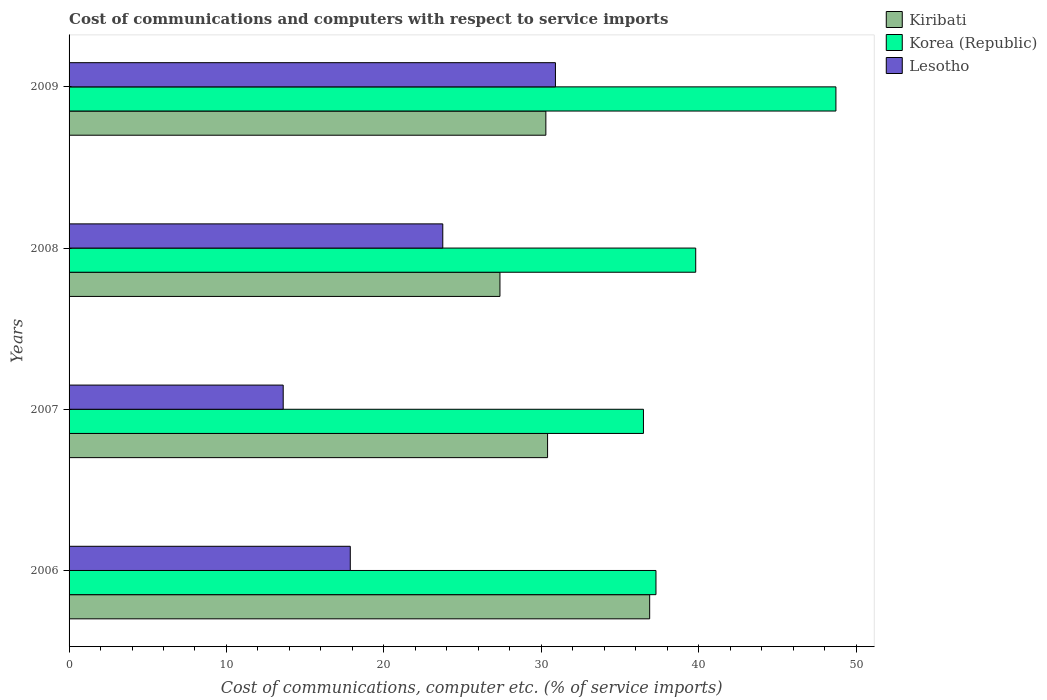Are the number of bars per tick equal to the number of legend labels?
Your answer should be very brief. Yes. Are the number of bars on each tick of the Y-axis equal?
Your answer should be compact. Yes. How many bars are there on the 3rd tick from the bottom?
Your answer should be compact. 3. In how many cases, is the number of bars for a given year not equal to the number of legend labels?
Your answer should be very brief. 0. What is the cost of communications and computers in Korea (Republic) in 2009?
Make the answer very short. 48.72. Across all years, what is the maximum cost of communications and computers in Lesotho?
Give a very brief answer. 30.9. Across all years, what is the minimum cost of communications and computers in Kiribati?
Your answer should be very brief. 27.38. What is the total cost of communications and computers in Kiribati in the graph?
Your answer should be compact. 124.96. What is the difference between the cost of communications and computers in Lesotho in 2006 and that in 2007?
Offer a very short reply. 4.26. What is the difference between the cost of communications and computers in Lesotho in 2009 and the cost of communications and computers in Korea (Republic) in 2008?
Your response must be concise. -8.91. What is the average cost of communications and computers in Lesotho per year?
Your response must be concise. 21.53. In the year 2008, what is the difference between the cost of communications and computers in Korea (Republic) and cost of communications and computers in Kiribati?
Ensure brevity in your answer.  12.44. In how many years, is the cost of communications and computers in Korea (Republic) greater than 2 %?
Keep it short and to the point. 4. What is the ratio of the cost of communications and computers in Kiribati in 2006 to that in 2008?
Offer a very short reply. 1.35. Is the cost of communications and computers in Kiribati in 2007 less than that in 2009?
Offer a very short reply. No. What is the difference between the highest and the second highest cost of communications and computers in Lesotho?
Provide a succinct answer. 7.16. What is the difference between the highest and the lowest cost of communications and computers in Kiribati?
Offer a terse response. 9.51. What does the 1st bar from the top in 2009 represents?
Give a very brief answer. Lesotho. How many years are there in the graph?
Make the answer very short. 4. What is the difference between two consecutive major ticks on the X-axis?
Offer a terse response. 10. Are the values on the major ticks of X-axis written in scientific E-notation?
Your answer should be very brief. No. How many legend labels are there?
Your answer should be very brief. 3. What is the title of the graph?
Your answer should be very brief. Cost of communications and computers with respect to service imports. Does "Hong Kong" appear as one of the legend labels in the graph?
Offer a very short reply. No. What is the label or title of the X-axis?
Ensure brevity in your answer.  Cost of communications, computer etc. (% of service imports). What is the Cost of communications, computer etc. (% of service imports) of Kiribati in 2006?
Provide a short and direct response. 36.89. What is the Cost of communications, computer etc. (% of service imports) in Korea (Republic) in 2006?
Your response must be concise. 37.29. What is the Cost of communications, computer etc. (% of service imports) of Lesotho in 2006?
Provide a short and direct response. 17.87. What is the Cost of communications, computer etc. (% of service imports) in Kiribati in 2007?
Keep it short and to the point. 30.4. What is the Cost of communications, computer etc. (% of service imports) in Korea (Republic) in 2007?
Ensure brevity in your answer.  36.49. What is the Cost of communications, computer etc. (% of service imports) of Lesotho in 2007?
Keep it short and to the point. 13.6. What is the Cost of communications, computer etc. (% of service imports) in Kiribati in 2008?
Offer a terse response. 27.38. What is the Cost of communications, computer etc. (% of service imports) in Korea (Republic) in 2008?
Your answer should be compact. 39.81. What is the Cost of communications, computer etc. (% of service imports) in Lesotho in 2008?
Your response must be concise. 23.74. What is the Cost of communications, computer etc. (% of service imports) in Kiribati in 2009?
Offer a very short reply. 30.29. What is the Cost of communications, computer etc. (% of service imports) of Korea (Republic) in 2009?
Provide a succinct answer. 48.72. What is the Cost of communications, computer etc. (% of service imports) in Lesotho in 2009?
Your answer should be compact. 30.9. Across all years, what is the maximum Cost of communications, computer etc. (% of service imports) in Kiribati?
Provide a short and direct response. 36.89. Across all years, what is the maximum Cost of communications, computer etc. (% of service imports) of Korea (Republic)?
Provide a short and direct response. 48.72. Across all years, what is the maximum Cost of communications, computer etc. (% of service imports) in Lesotho?
Provide a succinct answer. 30.9. Across all years, what is the minimum Cost of communications, computer etc. (% of service imports) in Kiribati?
Provide a succinct answer. 27.38. Across all years, what is the minimum Cost of communications, computer etc. (% of service imports) in Korea (Republic)?
Your answer should be very brief. 36.49. Across all years, what is the minimum Cost of communications, computer etc. (% of service imports) of Lesotho?
Ensure brevity in your answer.  13.6. What is the total Cost of communications, computer etc. (% of service imports) of Kiribati in the graph?
Keep it short and to the point. 124.96. What is the total Cost of communications, computer etc. (% of service imports) in Korea (Republic) in the graph?
Your response must be concise. 162.32. What is the total Cost of communications, computer etc. (% of service imports) in Lesotho in the graph?
Ensure brevity in your answer.  86.12. What is the difference between the Cost of communications, computer etc. (% of service imports) of Kiribati in 2006 and that in 2007?
Ensure brevity in your answer.  6.49. What is the difference between the Cost of communications, computer etc. (% of service imports) of Korea (Republic) in 2006 and that in 2007?
Give a very brief answer. 0.8. What is the difference between the Cost of communications, computer etc. (% of service imports) of Lesotho in 2006 and that in 2007?
Ensure brevity in your answer.  4.26. What is the difference between the Cost of communications, computer etc. (% of service imports) of Kiribati in 2006 and that in 2008?
Your answer should be compact. 9.51. What is the difference between the Cost of communications, computer etc. (% of service imports) of Korea (Republic) in 2006 and that in 2008?
Give a very brief answer. -2.53. What is the difference between the Cost of communications, computer etc. (% of service imports) of Lesotho in 2006 and that in 2008?
Give a very brief answer. -5.88. What is the difference between the Cost of communications, computer etc. (% of service imports) in Kiribati in 2006 and that in 2009?
Offer a very short reply. 6.6. What is the difference between the Cost of communications, computer etc. (% of service imports) of Korea (Republic) in 2006 and that in 2009?
Make the answer very short. -11.43. What is the difference between the Cost of communications, computer etc. (% of service imports) in Lesotho in 2006 and that in 2009?
Provide a short and direct response. -13.03. What is the difference between the Cost of communications, computer etc. (% of service imports) in Kiribati in 2007 and that in 2008?
Offer a very short reply. 3.03. What is the difference between the Cost of communications, computer etc. (% of service imports) of Korea (Republic) in 2007 and that in 2008?
Make the answer very short. -3.32. What is the difference between the Cost of communications, computer etc. (% of service imports) of Lesotho in 2007 and that in 2008?
Provide a succinct answer. -10.14. What is the difference between the Cost of communications, computer etc. (% of service imports) of Kiribati in 2007 and that in 2009?
Your answer should be very brief. 0.11. What is the difference between the Cost of communications, computer etc. (% of service imports) in Korea (Republic) in 2007 and that in 2009?
Your answer should be very brief. -12.23. What is the difference between the Cost of communications, computer etc. (% of service imports) of Lesotho in 2007 and that in 2009?
Your answer should be very brief. -17.3. What is the difference between the Cost of communications, computer etc. (% of service imports) in Kiribati in 2008 and that in 2009?
Your answer should be compact. -2.92. What is the difference between the Cost of communications, computer etc. (% of service imports) of Korea (Republic) in 2008 and that in 2009?
Provide a short and direct response. -8.91. What is the difference between the Cost of communications, computer etc. (% of service imports) in Lesotho in 2008 and that in 2009?
Offer a very short reply. -7.16. What is the difference between the Cost of communications, computer etc. (% of service imports) in Kiribati in 2006 and the Cost of communications, computer etc. (% of service imports) in Korea (Republic) in 2007?
Keep it short and to the point. 0.4. What is the difference between the Cost of communications, computer etc. (% of service imports) of Kiribati in 2006 and the Cost of communications, computer etc. (% of service imports) of Lesotho in 2007?
Offer a very short reply. 23.28. What is the difference between the Cost of communications, computer etc. (% of service imports) of Korea (Republic) in 2006 and the Cost of communications, computer etc. (% of service imports) of Lesotho in 2007?
Offer a terse response. 23.68. What is the difference between the Cost of communications, computer etc. (% of service imports) of Kiribati in 2006 and the Cost of communications, computer etc. (% of service imports) of Korea (Republic) in 2008?
Give a very brief answer. -2.93. What is the difference between the Cost of communications, computer etc. (% of service imports) of Kiribati in 2006 and the Cost of communications, computer etc. (% of service imports) of Lesotho in 2008?
Make the answer very short. 13.14. What is the difference between the Cost of communications, computer etc. (% of service imports) of Korea (Republic) in 2006 and the Cost of communications, computer etc. (% of service imports) of Lesotho in 2008?
Your answer should be very brief. 13.54. What is the difference between the Cost of communications, computer etc. (% of service imports) in Kiribati in 2006 and the Cost of communications, computer etc. (% of service imports) in Korea (Republic) in 2009?
Offer a terse response. -11.83. What is the difference between the Cost of communications, computer etc. (% of service imports) of Kiribati in 2006 and the Cost of communications, computer etc. (% of service imports) of Lesotho in 2009?
Your response must be concise. 5.99. What is the difference between the Cost of communications, computer etc. (% of service imports) of Korea (Republic) in 2006 and the Cost of communications, computer etc. (% of service imports) of Lesotho in 2009?
Ensure brevity in your answer.  6.39. What is the difference between the Cost of communications, computer etc. (% of service imports) in Kiribati in 2007 and the Cost of communications, computer etc. (% of service imports) in Korea (Republic) in 2008?
Offer a terse response. -9.41. What is the difference between the Cost of communications, computer etc. (% of service imports) of Kiribati in 2007 and the Cost of communications, computer etc. (% of service imports) of Lesotho in 2008?
Offer a terse response. 6.66. What is the difference between the Cost of communications, computer etc. (% of service imports) in Korea (Republic) in 2007 and the Cost of communications, computer etc. (% of service imports) in Lesotho in 2008?
Give a very brief answer. 12.75. What is the difference between the Cost of communications, computer etc. (% of service imports) in Kiribati in 2007 and the Cost of communications, computer etc. (% of service imports) in Korea (Republic) in 2009?
Your response must be concise. -18.32. What is the difference between the Cost of communications, computer etc. (% of service imports) of Kiribati in 2007 and the Cost of communications, computer etc. (% of service imports) of Lesotho in 2009?
Your answer should be compact. -0.5. What is the difference between the Cost of communications, computer etc. (% of service imports) of Korea (Republic) in 2007 and the Cost of communications, computer etc. (% of service imports) of Lesotho in 2009?
Offer a terse response. 5.59. What is the difference between the Cost of communications, computer etc. (% of service imports) of Kiribati in 2008 and the Cost of communications, computer etc. (% of service imports) of Korea (Republic) in 2009?
Your answer should be compact. -21.35. What is the difference between the Cost of communications, computer etc. (% of service imports) of Kiribati in 2008 and the Cost of communications, computer etc. (% of service imports) of Lesotho in 2009?
Your answer should be very brief. -3.53. What is the difference between the Cost of communications, computer etc. (% of service imports) in Korea (Republic) in 2008 and the Cost of communications, computer etc. (% of service imports) in Lesotho in 2009?
Make the answer very short. 8.91. What is the average Cost of communications, computer etc. (% of service imports) of Kiribati per year?
Ensure brevity in your answer.  31.24. What is the average Cost of communications, computer etc. (% of service imports) in Korea (Republic) per year?
Keep it short and to the point. 40.58. What is the average Cost of communications, computer etc. (% of service imports) of Lesotho per year?
Provide a short and direct response. 21.53. In the year 2006, what is the difference between the Cost of communications, computer etc. (% of service imports) in Kiribati and Cost of communications, computer etc. (% of service imports) in Korea (Republic)?
Your response must be concise. -0.4. In the year 2006, what is the difference between the Cost of communications, computer etc. (% of service imports) in Kiribati and Cost of communications, computer etc. (% of service imports) in Lesotho?
Offer a very short reply. 19.02. In the year 2006, what is the difference between the Cost of communications, computer etc. (% of service imports) in Korea (Republic) and Cost of communications, computer etc. (% of service imports) in Lesotho?
Your response must be concise. 19.42. In the year 2007, what is the difference between the Cost of communications, computer etc. (% of service imports) in Kiribati and Cost of communications, computer etc. (% of service imports) in Korea (Republic)?
Offer a terse response. -6.09. In the year 2007, what is the difference between the Cost of communications, computer etc. (% of service imports) of Kiribati and Cost of communications, computer etc. (% of service imports) of Lesotho?
Offer a very short reply. 16.8. In the year 2007, what is the difference between the Cost of communications, computer etc. (% of service imports) of Korea (Republic) and Cost of communications, computer etc. (% of service imports) of Lesotho?
Give a very brief answer. 22.89. In the year 2008, what is the difference between the Cost of communications, computer etc. (% of service imports) of Kiribati and Cost of communications, computer etc. (% of service imports) of Korea (Republic)?
Provide a succinct answer. -12.44. In the year 2008, what is the difference between the Cost of communications, computer etc. (% of service imports) in Kiribati and Cost of communications, computer etc. (% of service imports) in Lesotho?
Offer a very short reply. 3.63. In the year 2008, what is the difference between the Cost of communications, computer etc. (% of service imports) of Korea (Republic) and Cost of communications, computer etc. (% of service imports) of Lesotho?
Provide a short and direct response. 16.07. In the year 2009, what is the difference between the Cost of communications, computer etc. (% of service imports) in Kiribati and Cost of communications, computer etc. (% of service imports) in Korea (Republic)?
Your answer should be very brief. -18.43. In the year 2009, what is the difference between the Cost of communications, computer etc. (% of service imports) in Kiribati and Cost of communications, computer etc. (% of service imports) in Lesotho?
Provide a short and direct response. -0.61. In the year 2009, what is the difference between the Cost of communications, computer etc. (% of service imports) of Korea (Republic) and Cost of communications, computer etc. (% of service imports) of Lesotho?
Your response must be concise. 17.82. What is the ratio of the Cost of communications, computer etc. (% of service imports) of Kiribati in 2006 to that in 2007?
Provide a short and direct response. 1.21. What is the ratio of the Cost of communications, computer etc. (% of service imports) of Korea (Republic) in 2006 to that in 2007?
Provide a short and direct response. 1.02. What is the ratio of the Cost of communications, computer etc. (% of service imports) in Lesotho in 2006 to that in 2007?
Your answer should be compact. 1.31. What is the ratio of the Cost of communications, computer etc. (% of service imports) of Kiribati in 2006 to that in 2008?
Ensure brevity in your answer.  1.35. What is the ratio of the Cost of communications, computer etc. (% of service imports) in Korea (Republic) in 2006 to that in 2008?
Ensure brevity in your answer.  0.94. What is the ratio of the Cost of communications, computer etc. (% of service imports) of Lesotho in 2006 to that in 2008?
Your answer should be very brief. 0.75. What is the ratio of the Cost of communications, computer etc. (% of service imports) in Kiribati in 2006 to that in 2009?
Your response must be concise. 1.22. What is the ratio of the Cost of communications, computer etc. (% of service imports) of Korea (Republic) in 2006 to that in 2009?
Give a very brief answer. 0.77. What is the ratio of the Cost of communications, computer etc. (% of service imports) of Lesotho in 2006 to that in 2009?
Offer a very short reply. 0.58. What is the ratio of the Cost of communications, computer etc. (% of service imports) of Kiribati in 2007 to that in 2008?
Your answer should be very brief. 1.11. What is the ratio of the Cost of communications, computer etc. (% of service imports) of Korea (Republic) in 2007 to that in 2008?
Your answer should be very brief. 0.92. What is the ratio of the Cost of communications, computer etc. (% of service imports) in Lesotho in 2007 to that in 2008?
Your answer should be compact. 0.57. What is the ratio of the Cost of communications, computer etc. (% of service imports) in Kiribati in 2007 to that in 2009?
Offer a very short reply. 1. What is the ratio of the Cost of communications, computer etc. (% of service imports) of Korea (Republic) in 2007 to that in 2009?
Your answer should be compact. 0.75. What is the ratio of the Cost of communications, computer etc. (% of service imports) of Lesotho in 2007 to that in 2009?
Provide a short and direct response. 0.44. What is the ratio of the Cost of communications, computer etc. (% of service imports) of Kiribati in 2008 to that in 2009?
Offer a terse response. 0.9. What is the ratio of the Cost of communications, computer etc. (% of service imports) of Korea (Republic) in 2008 to that in 2009?
Keep it short and to the point. 0.82. What is the ratio of the Cost of communications, computer etc. (% of service imports) of Lesotho in 2008 to that in 2009?
Your answer should be very brief. 0.77. What is the difference between the highest and the second highest Cost of communications, computer etc. (% of service imports) of Kiribati?
Ensure brevity in your answer.  6.49. What is the difference between the highest and the second highest Cost of communications, computer etc. (% of service imports) in Korea (Republic)?
Your answer should be very brief. 8.91. What is the difference between the highest and the second highest Cost of communications, computer etc. (% of service imports) in Lesotho?
Ensure brevity in your answer.  7.16. What is the difference between the highest and the lowest Cost of communications, computer etc. (% of service imports) of Kiribati?
Your answer should be compact. 9.51. What is the difference between the highest and the lowest Cost of communications, computer etc. (% of service imports) in Korea (Republic)?
Your answer should be compact. 12.23. What is the difference between the highest and the lowest Cost of communications, computer etc. (% of service imports) in Lesotho?
Ensure brevity in your answer.  17.3. 